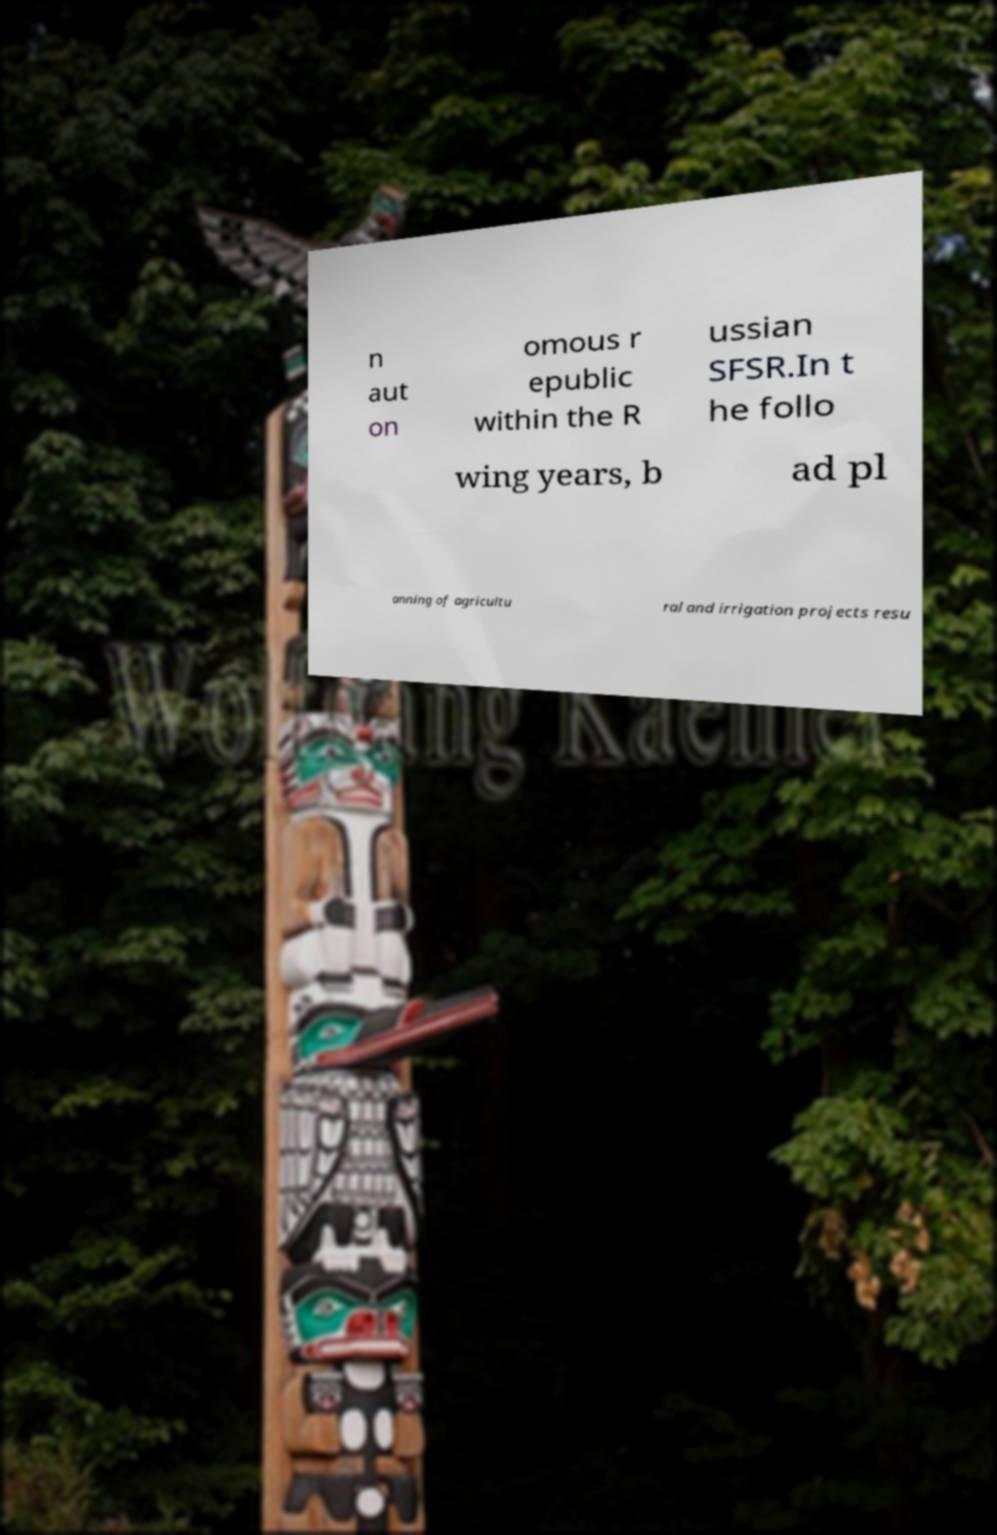Could you extract and type out the text from this image? n aut on omous r epublic within the R ussian SFSR.In t he follo wing years, b ad pl anning of agricultu ral and irrigation projects resu 